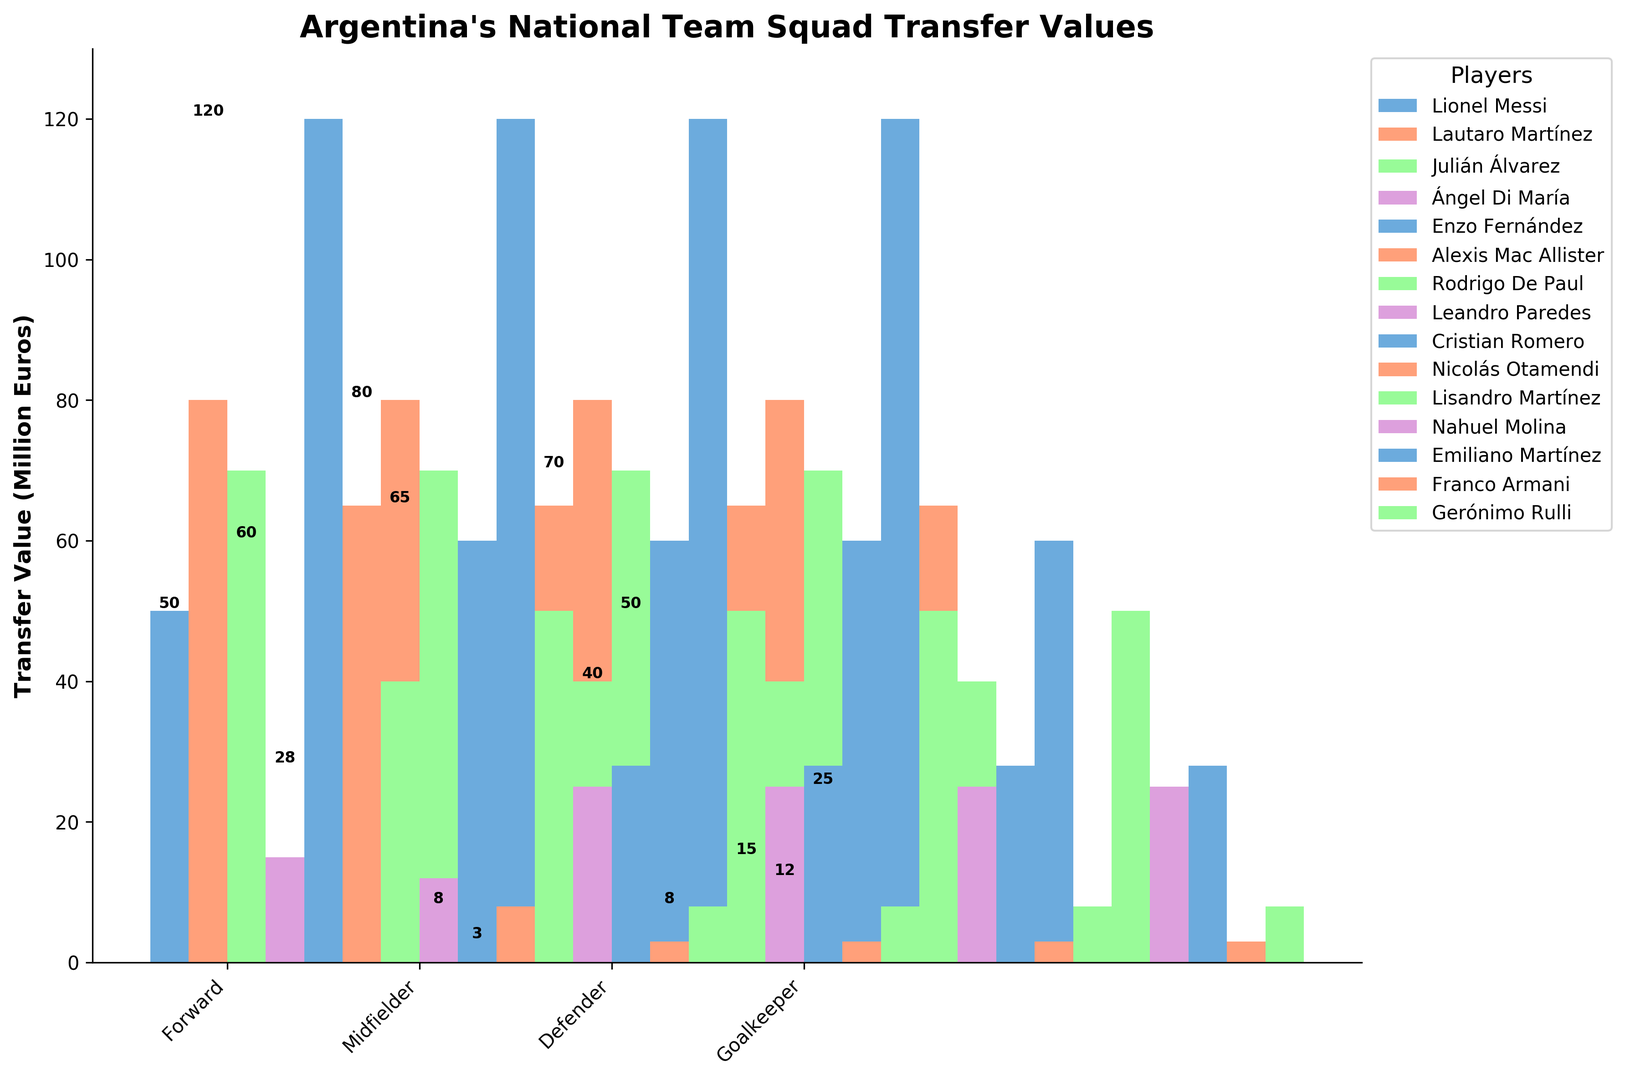Which player has the highest transfer value among midfielders? First, we need to identify the midfielders: Enzo Fernández, Alexis Mac Allister, Rodrigo De Paul, and Leandro Paredes. According to the figure, Enzo Fernández has the highest transfer value at 120 million euros.
Answer: Enzo Fernández What is the total transfer value of all forwards combined? We need to sum the transfer values of forwards: Lionel Messi (50), Lautaro Martínez (80), Julián Álvarez (70), and Ángel Di María (15). The total transfer value is 50 + 80 + 70 + 15 = 215 million euros.
Answer: 215 million euros Among the goalkeepers, who has the lowest transfer value? First, identify the goalkeepers: Emiliano Martínez, Franco Armani, and Gerónimo Rulli. According to the figure, Franco Armani has the lowest transfer value at 3 million euros.
Answer: Franco Armani Compare the transfer values of Lionel Messi and Julián Álvarez. Who is valued higher? The transfer value of Lionel Messi is 50 million euros and the transfer value of Julián Álvarez is 70 million euros. According to the figure, Julián Álvarez is valued higher.
Answer: Julián Álvarez What is the average transfer value of defenders? We need to calculate the average by summing up the transfer values of defenders: Cristian Romero (60), Nicolás Otamendi (8), Lisandro Martínez (50), and Nahuel Molina (25), which sums up to 143. Then divide by the number of defenders: 143/4 = 35.75 million euros.
Answer: 35.75 million euros How much more is Enzo Fernández valued compared to Alexis Mac Allister? Enzo Fernández has a transfer value of 120 million euros and Alexis Mac Allister has 65 million euros. The difference in their values is 120 - 65 = 55 million euros.
Answer: 55 million euros Which player has the lowest transfer value overall and what is it? According to the figure, Franco Armani has the lowest transfer value at 3 million euros.
Answer: Franco Armani with 3 million euros Identify the player with the highest transfer value and their position. According to the figure, Enzo Fernández has the highest transfer value of 120 million euros and he is a midfielder.
Answer: Enzo Fernández, midfielder How does the transfer value of Cristian Romero compare to that of Rodrigo De Paul? Cristian Romero has a transfer value of 60 million euros and Rodrigo De Paul has 40 million euros. Hence, Cristian Romero is valued higher.
Answer: Cristian Romero 